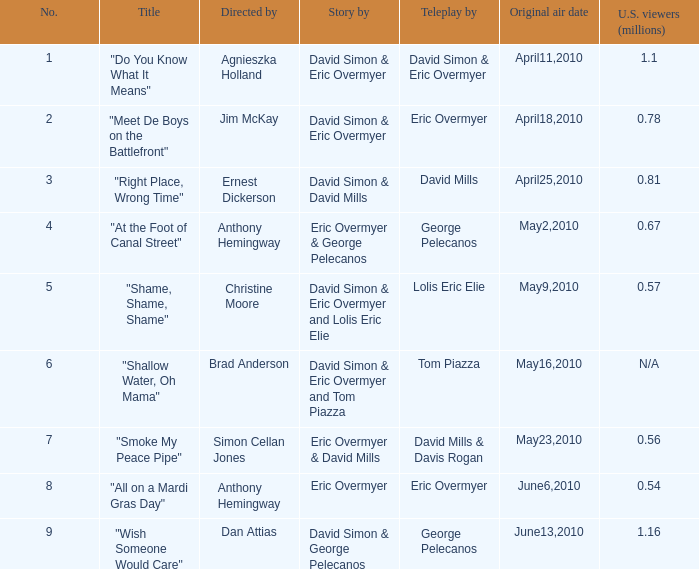Give me the full table as a dictionary. {'header': ['No.', 'Title', 'Directed by', 'Story by', 'Teleplay by', 'Original air date', 'U.S. viewers (millions)'], 'rows': [['1', '"Do You Know What It Means"', 'Agnieszka Holland', 'David Simon & Eric Overmyer', 'David Simon & Eric Overmyer', 'April11,2010', '1.1'], ['2', '"Meet De Boys on the Battlefront"', 'Jim McKay', 'David Simon & Eric Overmyer', 'Eric Overmyer', 'April18,2010', '0.78'], ['3', '"Right Place, Wrong Time"', 'Ernest Dickerson', 'David Simon & David Mills', 'David Mills', 'April25,2010', '0.81'], ['4', '"At the Foot of Canal Street"', 'Anthony Hemingway', 'Eric Overmyer & George Pelecanos', 'George Pelecanos', 'May2,2010', '0.67'], ['5', '"Shame, Shame, Shame"', 'Christine Moore', 'David Simon & Eric Overmyer and Lolis Eric Elie', 'Lolis Eric Elie', 'May9,2010', '0.57'], ['6', '"Shallow Water, Oh Mama"', 'Brad Anderson', 'David Simon & Eric Overmyer and Tom Piazza', 'Tom Piazza', 'May16,2010', 'N/A'], ['7', '"Smoke My Peace Pipe"', 'Simon Cellan Jones', 'Eric Overmyer & David Mills', 'David Mills & Davis Rogan', 'May23,2010', '0.56'], ['8', '"All on a Mardi Gras Day"', 'Anthony Hemingway', 'Eric Overmyer', 'Eric Overmyer', 'June6,2010', '0.54'], ['9', '"Wish Someone Would Care"', 'Dan Attias', 'David Simon & George Pelecanos', 'George Pelecanos', 'June13,2010', '1.16']]} Name the teleplay for  david simon & eric overmyer and tom piazza Tom Piazza. 